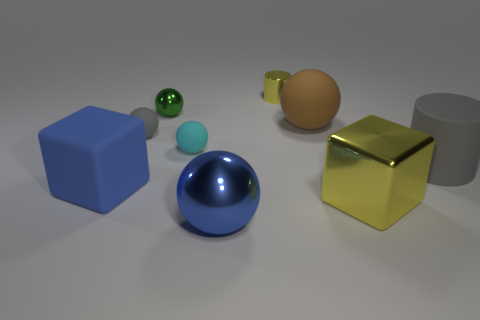Are there fewer rubber things that are in front of the big gray cylinder than objects? yes 